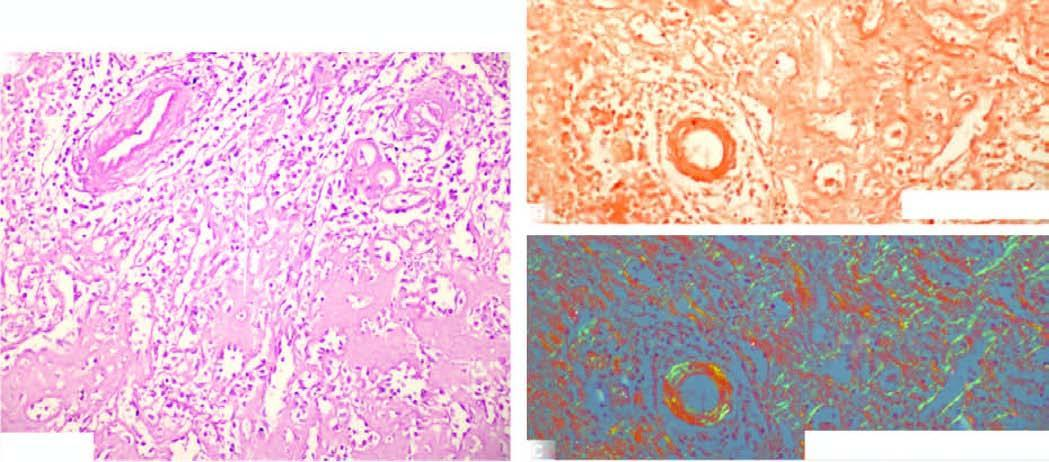does equence of events in the pathogenesis of reversible and irreversible cell injury show congophilia as seen by red-pink colour?
Answer the question using a single word or phrase. No 